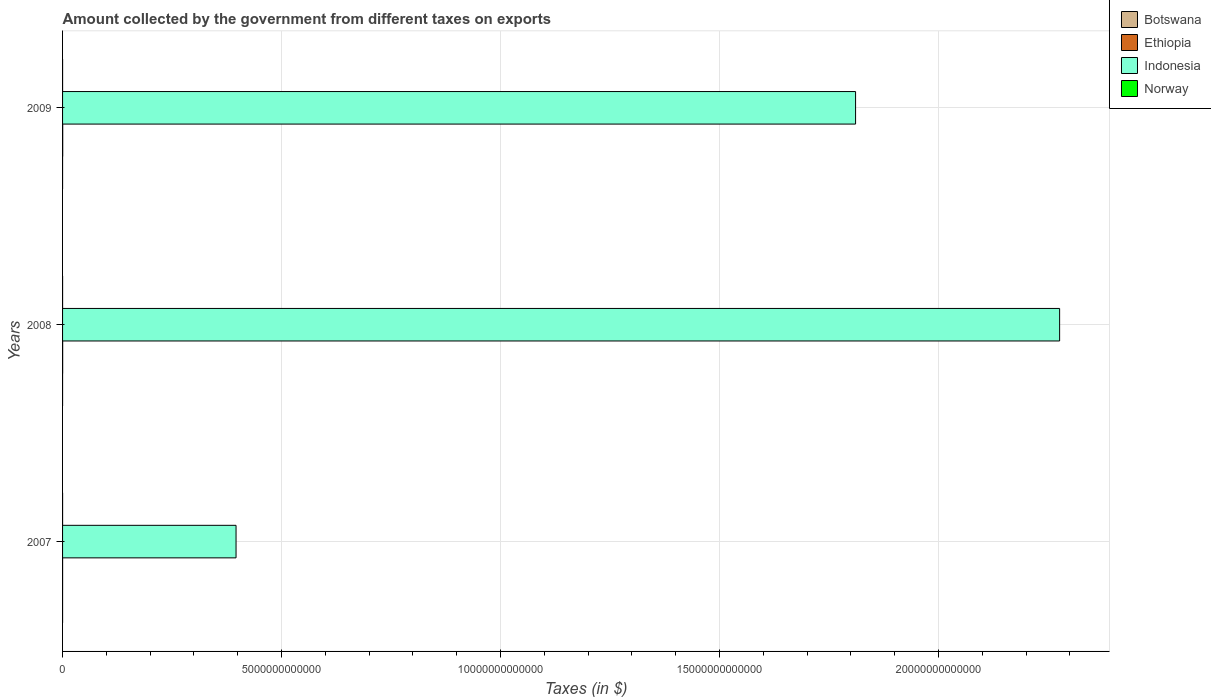How many different coloured bars are there?
Offer a terse response. 4. Are the number of bars on each tick of the Y-axis equal?
Keep it short and to the point. Yes. How many bars are there on the 3rd tick from the top?
Ensure brevity in your answer.  4. How many bars are there on the 2nd tick from the bottom?
Your answer should be very brief. 4. What is the label of the 1st group of bars from the top?
Offer a very short reply. 2009. What is the amount collected by the government from taxes on exports in Botswana in 2009?
Offer a very short reply. 7.10e+05. Across all years, what is the maximum amount collected by the government from taxes on exports in Norway?
Provide a short and direct response. 1.30e+08. Across all years, what is the minimum amount collected by the government from taxes on exports in Botswana?
Make the answer very short. 4.40e+05. What is the total amount collected by the government from taxes on exports in Botswana in the graph?
Offer a very short reply. 2.80e+06. What is the difference between the amount collected by the government from taxes on exports in Indonesia in 2007 and that in 2009?
Make the answer very short. -1.41e+13. What is the difference between the amount collected by the government from taxes on exports in Indonesia in 2009 and the amount collected by the government from taxes on exports in Botswana in 2008?
Make the answer very short. 1.81e+13. What is the average amount collected by the government from taxes on exports in Indonesia per year?
Offer a terse response. 1.49e+13. In the year 2007, what is the difference between the amount collected by the government from taxes on exports in Norway and amount collected by the government from taxes on exports in Ethiopia?
Provide a succinct answer. -3.83e+08. In how many years, is the amount collected by the government from taxes on exports in Ethiopia greater than 5000000000000 $?
Your answer should be compact. 0. What is the ratio of the amount collected by the government from taxes on exports in Botswana in 2007 to that in 2009?
Keep it short and to the point. 0.62. Is the amount collected by the government from taxes on exports in Botswana in 2007 less than that in 2009?
Your answer should be very brief. Yes. Is the difference between the amount collected by the government from taxes on exports in Norway in 2007 and 2009 greater than the difference between the amount collected by the government from taxes on exports in Ethiopia in 2007 and 2009?
Give a very brief answer. Yes. What is the difference between the highest and the second highest amount collected by the government from taxes on exports in Norway?
Keep it short and to the point. 1.00e+07. What is the difference between the highest and the lowest amount collected by the government from taxes on exports in Indonesia?
Your answer should be compact. 1.88e+13. Is the sum of the amount collected by the government from taxes on exports in Ethiopia in 2008 and 2009 greater than the maximum amount collected by the government from taxes on exports in Botswana across all years?
Offer a terse response. Yes. Is it the case that in every year, the sum of the amount collected by the government from taxes on exports in Ethiopia and amount collected by the government from taxes on exports in Norway is greater than the sum of amount collected by the government from taxes on exports in Indonesia and amount collected by the government from taxes on exports in Botswana?
Your answer should be very brief. No. What does the 2nd bar from the top in 2007 represents?
Your answer should be very brief. Indonesia. What does the 2nd bar from the bottom in 2007 represents?
Provide a short and direct response. Ethiopia. Is it the case that in every year, the sum of the amount collected by the government from taxes on exports in Ethiopia and amount collected by the government from taxes on exports in Botswana is greater than the amount collected by the government from taxes on exports in Indonesia?
Provide a short and direct response. No. How many bars are there?
Give a very brief answer. 12. How many years are there in the graph?
Offer a very short reply. 3. What is the difference between two consecutive major ticks on the X-axis?
Make the answer very short. 5.00e+12. Are the values on the major ticks of X-axis written in scientific E-notation?
Keep it short and to the point. No. Does the graph contain any zero values?
Offer a terse response. No. Where does the legend appear in the graph?
Provide a short and direct response. Top right. What is the title of the graph?
Offer a terse response. Amount collected by the government from different taxes on exports. What is the label or title of the X-axis?
Provide a short and direct response. Taxes (in $). What is the Taxes (in $) of Ethiopia in 2007?
Provide a short and direct response. 4.93e+08. What is the Taxes (in $) in Indonesia in 2007?
Ensure brevity in your answer.  3.96e+12. What is the Taxes (in $) of Norway in 2007?
Your answer should be compact. 1.10e+08. What is the Taxes (in $) in Botswana in 2008?
Your answer should be compact. 1.65e+06. What is the Taxes (in $) of Ethiopia in 2008?
Offer a terse response. 2.11e+09. What is the Taxes (in $) in Indonesia in 2008?
Offer a very short reply. 2.28e+13. What is the Taxes (in $) in Norway in 2008?
Give a very brief answer. 1.20e+08. What is the Taxes (in $) of Botswana in 2009?
Your answer should be very brief. 7.10e+05. What is the Taxes (in $) in Ethiopia in 2009?
Offer a terse response. 3.23e+09. What is the Taxes (in $) of Indonesia in 2009?
Your answer should be compact. 1.81e+13. What is the Taxes (in $) in Norway in 2009?
Offer a terse response. 1.30e+08. Across all years, what is the maximum Taxes (in $) of Botswana?
Your answer should be very brief. 1.65e+06. Across all years, what is the maximum Taxes (in $) of Ethiopia?
Provide a succinct answer. 3.23e+09. Across all years, what is the maximum Taxes (in $) of Indonesia?
Offer a very short reply. 2.28e+13. Across all years, what is the maximum Taxes (in $) in Norway?
Keep it short and to the point. 1.30e+08. Across all years, what is the minimum Taxes (in $) of Ethiopia?
Provide a succinct answer. 4.93e+08. Across all years, what is the minimum Taxes (in $) in Indonesia?
Make the answer very short. 3.96e+12. Across all years, what is the minimum Taxes (in $) of Norway?
Keep it short and to the point. 1.10e+08. What is the total Taxes (in $) in Botswana in the graph?
Your answer should be compact. 2.80e+06. What is the total Taxes (in $) in Ethiopia in the graph?
Provide a short and direct response. 5.84e+09. What is the total Taxes (in $) in Indonesia in the graph?
Your answer should be very brief. 4.48e+13. What is the total Taxes (in $) in Norway in the graph?
Offer a very short reply. 3.60e+08. What is the difference between the Taxes (in $) of Botswana in 2007 and that in 2008?
Your answer should be compact. -1.21e+06. What is the difference between the Taxes (in $) of Ethiopia in 2007 and that in 2008?
Your answer should be compact. -1.62e+09. What is the difference between the Taxes (in $) of Indonesia in 2007 and that in 2008?
Ensure brevity in your answer.  -1.88e+13. What is the difference between the Taxes (in $) in Norway in 2007 and that in 2008?
Provide a succinct answer. -1.00e+07. What is the difference between the Taxes (in $) of Ethiopia in 2007 and that in 2009?
Give a very brief answer. -2.74e+09. What is the difference between the Taxes (in $) in Indonesia in 2007 and that in 2009?
Your answer should be very brief. -1.41e+13. What is the difference between the Taxes (in $) of Norway in 2007 and that in 2009?
Give a very brief answer. -2.00e+07. What is the difference between the Taxes (in $) in Botswana in 2008 and that in 2009?
Offer a very short reply. 9.40e+05. What is the difference between the Taxes (in $) of Ethiopia in 2008 and that in 2009?
Provide a succinct answer. -1.12e+09. What is the difference between the Taxes (in $) of Indonesia in 2008 and that in 2009?
Your answer should be very brief. 4.66e+12. What is the difference between the Taxes (in $) of Norway in 2008 and that in 2009?
Keep it short and to the point. -1.00e+07. What is the difference between the Taxes (in $) in Botswana in 2007 and the Taxes (in $) in Ethiopia in 2008?
Offer a terse response. -2.11e+09. What is the difference between the Taxes (in $) in Botswana in 2007 and the Taxes (in $) in Indonesia in 2008?
Give a very brief answer. -2.28e+13. What is the difference between the Taxes (in $) of Botswana in 2007 and the Taxes (in $) of Norway in 2008?
Provide a short and direct response. -1.20e+08. What is the difference between the Taxes (in $) of Ethiopia in 2007 and the Taxes (in $) of Indonesia in 2008?
Offer a very short reply. -2.28e+13. What is the difference between the Taxes (in $) of Ethiopia in 2007 and the Taxes (in $) of Norway in 2008?
Offer a very short reply. 3.73e+08. What is the difference between the Taxes (in $) of Indonesia in 2007 and the Taxes (in $) of Norway in 2008?
Provide a short and direct response. 3.96e+12. What is the difference between the Taxes (in $) in Botswana in 2007 and the Taxes (in $) in Ethiopia in 2009?
Your answer should be compact. -3.23e+09. What is the difference between the Taxes (in $) of Botswana in 2007 and the Taxes (in $) of Indonesia in 2009?
Provide a short and direct response. -1.81e+13. What is the difference between the Taxes (in $) in Botswana in 2007 and the Taxes (in $) in Norway in 2009?
Provide a succinct answer. -1.30e+08. What is the difference between the Taxes (in $) of Ethiopia in 2007 and the Taxes (in $) of Indonesia in 2009?
Give a very brief answer. -1.81e+13. What is the difference between the Taxes (in $) in Ethiopia in 2007 and the Taxes (in $) in Norway in 2009?
Your response must be concise. 3.63e+08. What is the difference between the Taxes (in $) of Indonesia in 2007 and the Taxes (in $) of Norway in 2009?
Give a very brief answer. 3.96e+12. What is the difference between the Taxes (in $) of Botswana in 2008 and the Taxes (in $) of Ethiopia in 2009?
Keep it short and to the point. -3.23e+09. What is the difference between the Taxes (in $) of Botswana in 2008 and the Taxes (in $) of Indonesia in 2009?
Make the answer very short. -1.81e+13. What is the difference between the Taxes (in $) of Botswana in 2008 and the Taxes (in $) of Norway in 2009?
Give a very brief answer. -1.28e+08. What is the difference between the Taxes (in $) in Ethiopia in 2008 and the Taxes (in $) in Indonesia in 2009?
Provide a succinct answer. -1.81e+13. What is the difference between the Taxes (in $) of Ethiopia in 2008 and the Taxes (in $) of Norway in 2009?
Your answer should be compact. 1.98e+09. What is the difference between the Taxes (in $) in Indonesia in 2008 and the Taxes (in $) in Norway in 2009?
Provide a succinct answer. 2.28e+13. What is the average Taxes (in $) of Botswana per year?
Provide a short and direct response. 9.33e+05. What is the average Taxes (in $) of Ethiopia per year?
Your answer should be compact. 1.94e+09. What is the average Taxes (in $) of Indonesia per year?
Your answer should be compact. 1.49e+13. What is the average Taxes (in $) of Norway per year?
Make the answer very short. 1.20e+08. In the year 2007, what is the difference between the Taxes (in $) of Botswana and Taxes (in $) of Ethiopia?
Give a very brief answer. -4.93e+08. In the year 2007, what is the difference between the Taxes (in $) in Botswana and Taxes (in $) in Indonesia?
Your response must be concise. -3.96e+12. In the year 2007, what is the difference between the Taxes (in $) in Botswana and Taxes (in $) in Norway?
Provide a short and direct response. -1.10e+08. In the year 2007, what is the difference between the Taxes (in $) in Ethiopia and Taxes (in $) in Indonesia?
Offer a terse response. -3.96e+12. In the year 2007, what is the difference between the Taxes (in $) in Ethiopia and Taxes (in $) in Norway?
Ensure brevity in your answer.  3.83e+08. In the year 2007, what is the difference between the Taxes (in $) of Indonesia and Taxes (in $) of Norway?
Provide a succinct answer. 3.96e+12. In the year 2008, what is the difference between the Taxes (in $) in Botswana and Taxes (in $) in Ethiopia?
Ensure brevity in your answer.  -2.11e+09. In the year 2008, what is the difference between the Taxes (in $) of Botswana and Taxes (in $) of Indonesia?
Ensure brevity in your answer.  -2.28e+13. In the year 2008, what is the difference between the Taxes (in $) in Botswana and Taxes (in $) in Norway?
Your response must be concise. -1.18e+08. In the year 2008, what is the difference between the Taxes (in $) in Ethiopia and Taxes (in $) in Indonesia?
Give a very brief answer. -2.28e+13. In the year 2008, what is the difference between the Taxes (in $) in Ethiopia and Taxes (in $) in Norway?
Your answer should be compact. 1.99e+09. In the year 2008, what is the difference between the Taxes (in $) in Indonesia and Taxes (in $) in Norway?
Provide a succinct answer. 2.28e+13. In the year 2009, what is the difference between the Taxes (in $) in Botswana and Taxes (in $) in Ethiopia?
Make the answer very short. -3.23e+09. In the year 2009, what is the difference between the Taxes (in $) in Botswana and Taxes (in $) in Indonesia?
Your answer should be very brief. -1.81e+13. In the year 2009, what is the difference between the Taxes (in $) of Botswana and Taxes (in $) of Norway?
Your answer should be very brief. -1.29e+08. In the year 2009, what is the difference between the Taxes (in $) of Ethiopia and Taxes (in $) of Indonesia?
Offer a very short reply. -1.81e+13. In the year 2009, what is the difference between the Taxes (in $) in Ethiopia and Taxes (in $) in Norway?
Provide a succinct answer. 3.10e+09. In the year 2009, what is the difference between the Taxes (in $) in Indonesia and Taxes (in $) in Norway?
Make the answer very short. 1.81e+13. What is the ratio of the Taxes (in $) in Botswana in 2007 to that in 2008?
Keep it short and to the point. 0.27. What is the ratio of the Taxes (in $) of Ethiopia in 2007 to that in 2008?
Your answer should be very brief. 0.23. What is the ratio of the Taxes (in $) in Indonesia in 2007 to that in 2008?
Provide a short and direct response. 0.17. What is the ratio of the Taxes (in $) of Botswana in 2007 to that in 2009?
Provide a short and direct response. 0.62. What is the ratio of the Taxes (in $) in Ethiopia in 2007 to that in 2009?
Offer a terse response. 0.15. What is the ratio of the Taxes (in $) of Indonesia in 2007 to that in 2009?
Your answer should be very brief. 0.22. What is the ratio of the Taxes (in $) in Norway in 2007 to that in 2009?
Offer a very short reply. 0.85. What is the ratio of the Taxes (in $) of Botswana in 2008 to that in 2009?
Provide a short and direct response. 2.32. What is the ratio of the Taxes (in $) of Ethiopia in 2008 to that in 2009?
Provide a short and direct response. 0.65. What is the ratio of the Taxes (in $) of Indonesia in 2008 to that in 2009?
Provide a short and direct response. 1.26. What is the difference between the highest and the second highest Taxes (in $) of Botswana?
Your answer should be compact. 9.40e+05. What is the difference between the highest and the second highest Taxes (in $) in Ethiopia?
Provide a short and direct response. 1.12e+09. What is the difference between the highest and the second highest Taxes (in $) in Indonesia?
Make the answer very short. 4.66e+12. What is the difference between the highest and the lowest Taxes (in $) in Botswana?
Provide a short and direct response. 1.21e+06. What is the difference between the highest and the lowest Taxes (in $) of Ethiopia?
Offer a very short reply. 2.74e+09. What is the difference between the highest and the lowest Taxes (in $) in Indonesia?
Give a very brief answer. 1.88e+13. What is the difference between the highest and the lowest Taxes (in $) of Norway?
Your response must be concise. 2.00e+07. 